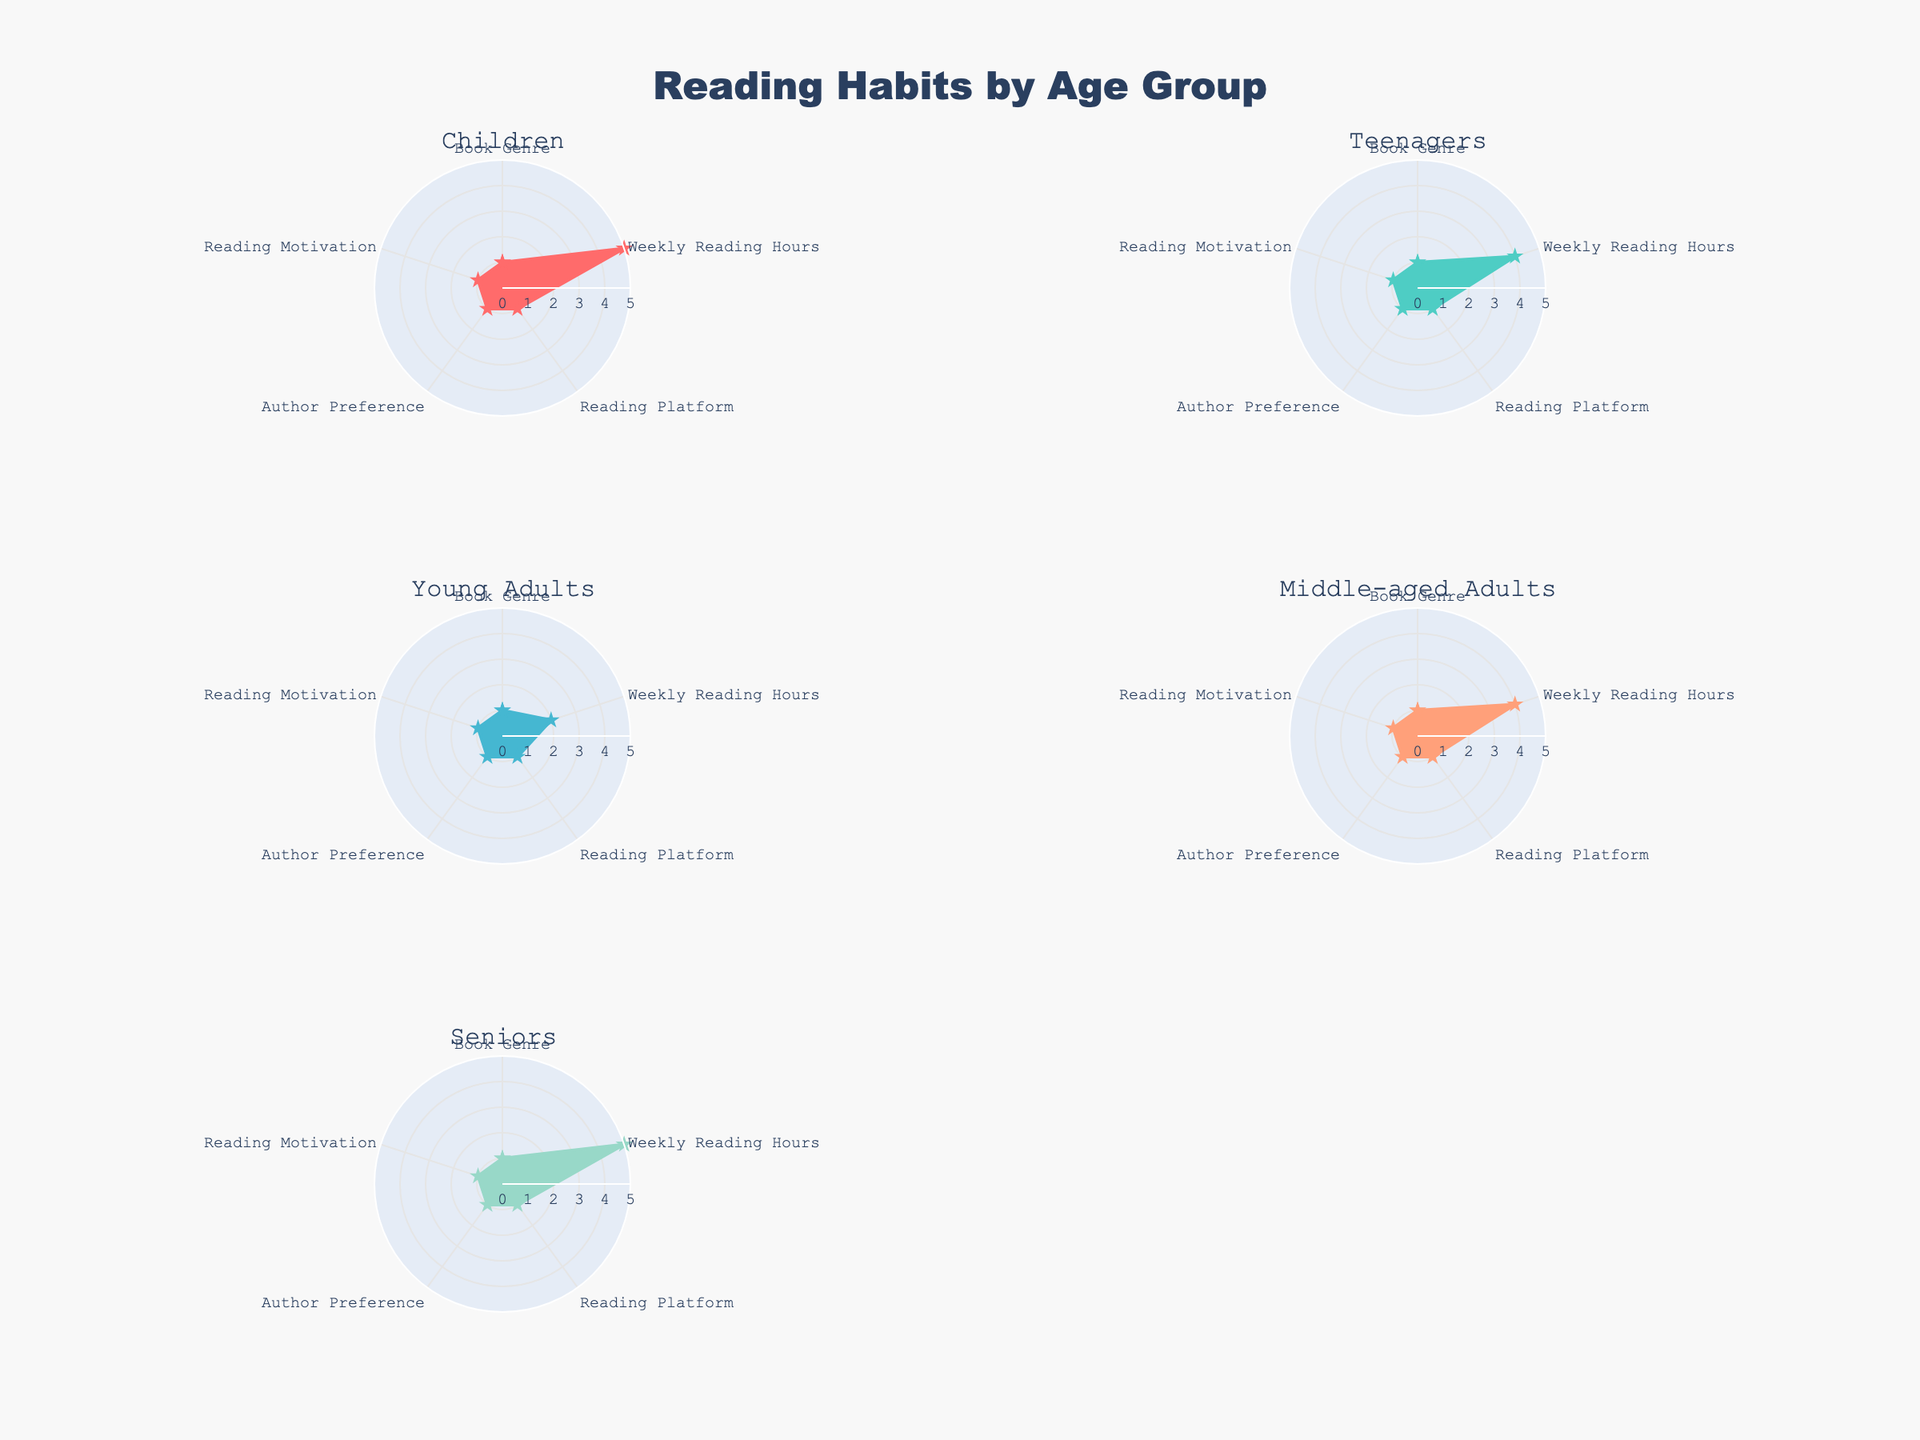What's the title of the figure? The title of the figure is written at the top and is usually in a larger or bold font to make it stand out. In this case, it is located at the center and reads "Reading Habits by Age Group".
Answer: Reading Habits by Age Group How many age groups are represented in the figure? There are six subplots, each for a different age group, and they are titled at the top of each subplot. Counting these titles gives the number of age groups.
Answer: Five Which age group spends the most weekly reading hours? Each subplot has a radial axis labeled "Weekly Reading Hours". By comparing the length of the radial axis for each group, the Children and Seniors groups are both seen to reach the highest values, with a value of 5.
Answer: Children and Seniors What type of reading platform is used most by the Middle-aged Adults? By observing the "Reading Platform" indicator on the Middle-aged Adults subplot, it shows the platform's associated value on the radar. Print Books and E-Books are seen equally, denoted by filled areas in the radar chart.
Answer: Both Print Books and E-Books What is the combined total of weekly reading hours for the "Children" and "Teenagers" groups? First find the weekly reading hours for each group and sum them up. Children have 5 hours and Teenagers have 4 hours. Adding these together gives the total weekly reading hours.
Answer: 9 hours How does the reading motivation of Young Adults compare to that of Middle-aged Adults? By observing the "Reading Motivation" in the radar chart of each subplot, Young Adults are mostly motivated by entertainment, intellectual curiosity, and self-improvement, while Middle-aged Adults are motivated by relaxation, intellectual curiosity, and self-improvement.
Answer: Entertainment vs. Relaxation Which author preference is unique to the Seniors group? Looking at the "Author Preference" shown in each subplot, Jane Austen, Barack Obama, and Max Lucado appear in the Seniors subplot but not in any other age groups, making Max Lucado particularly unique for his religious content.
Answer: Max Lucado Which group shows the highest value for "Intellectual Curiosity"? "Intellectual Curiosity" is a part of the overall radar values. Young adults and Middle-aged adults are notably pointed to representing an author preference for intellectual curiosity.
Answer: Young Adults and Middle-aged Adults What primary difference in book genres can be seen between Teenagers and Seniors? Observing the "Book Genre" in the radar plots for each group shows that Teenagers prefer Fantasy, Dystopian, and Romance books, whereas Seniors prefer Classics, Memoirs, and Religious texts.
Answer: Fantasy, Dystopian, Romance vs. Classics, Memoirs, Religious Which age group has the most diverse reading motivations? By examining each subplot's "Reading Motivation", note the different motivations marked in the plot. For Young Adults, motivations include entertainment, intellectual curiosity, and self-improvement, indicating high diversity.
Answer: Young Adults 